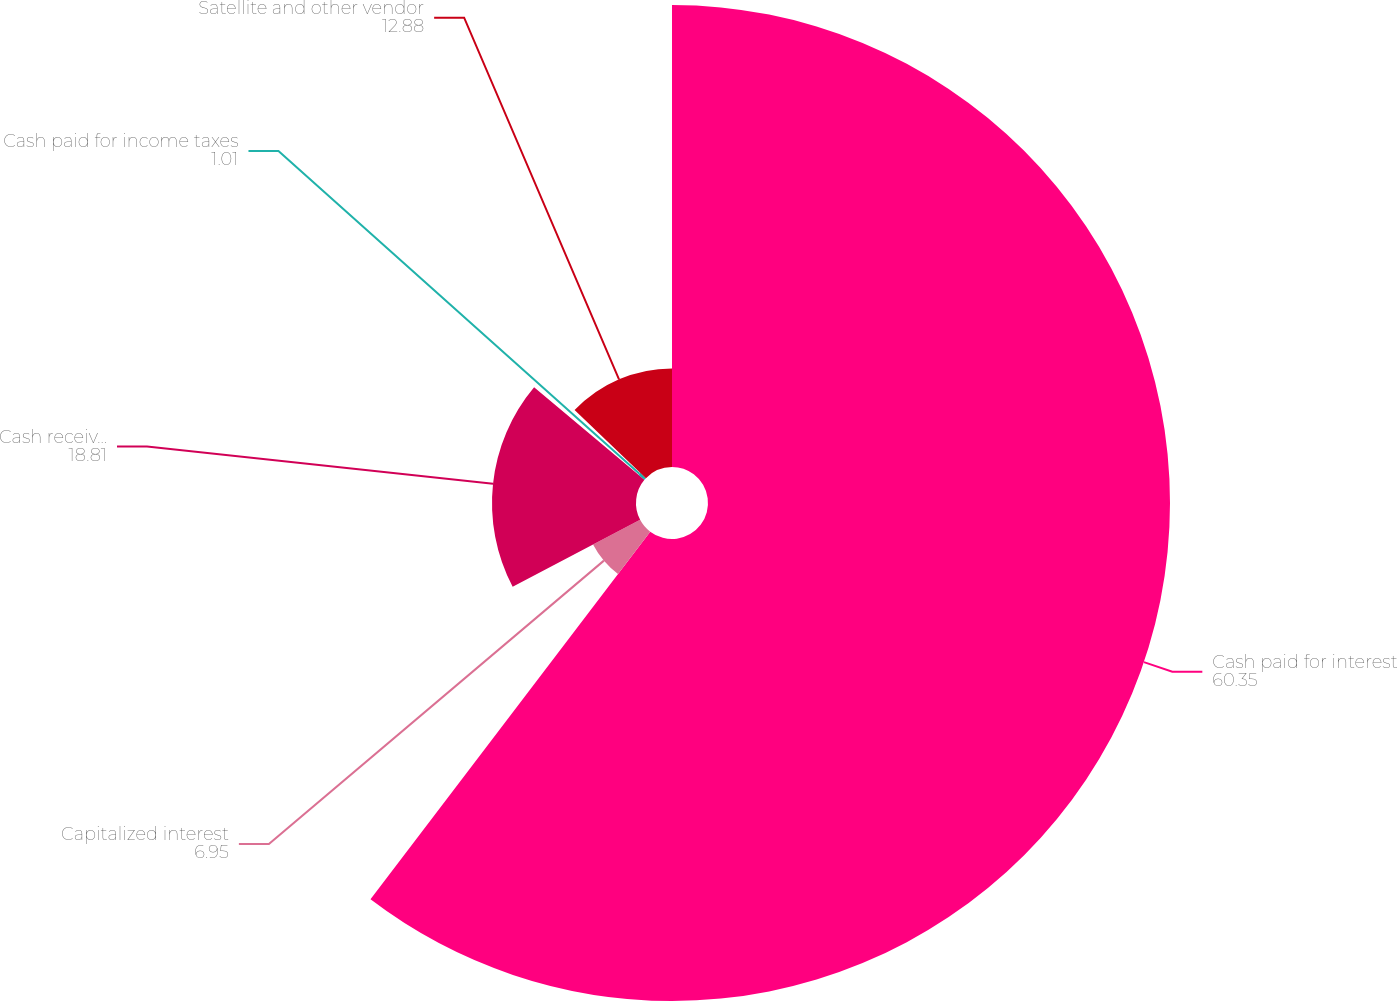Convert chart to OTSL. <chart><loc_0><loc_0><loc_500><loc_500><pie_chart><fcel>Cash paid for interest<fcel>Capitalized interest<fcel>Cash received for interest<fcel>Cash paid for income taxes<fcel>Satellite and other vendor<nl><fcel>60.35%<fcel>6.95%<fcel>18.81%<fcel>1.01%<fcel>12.88%<nl></chart> 